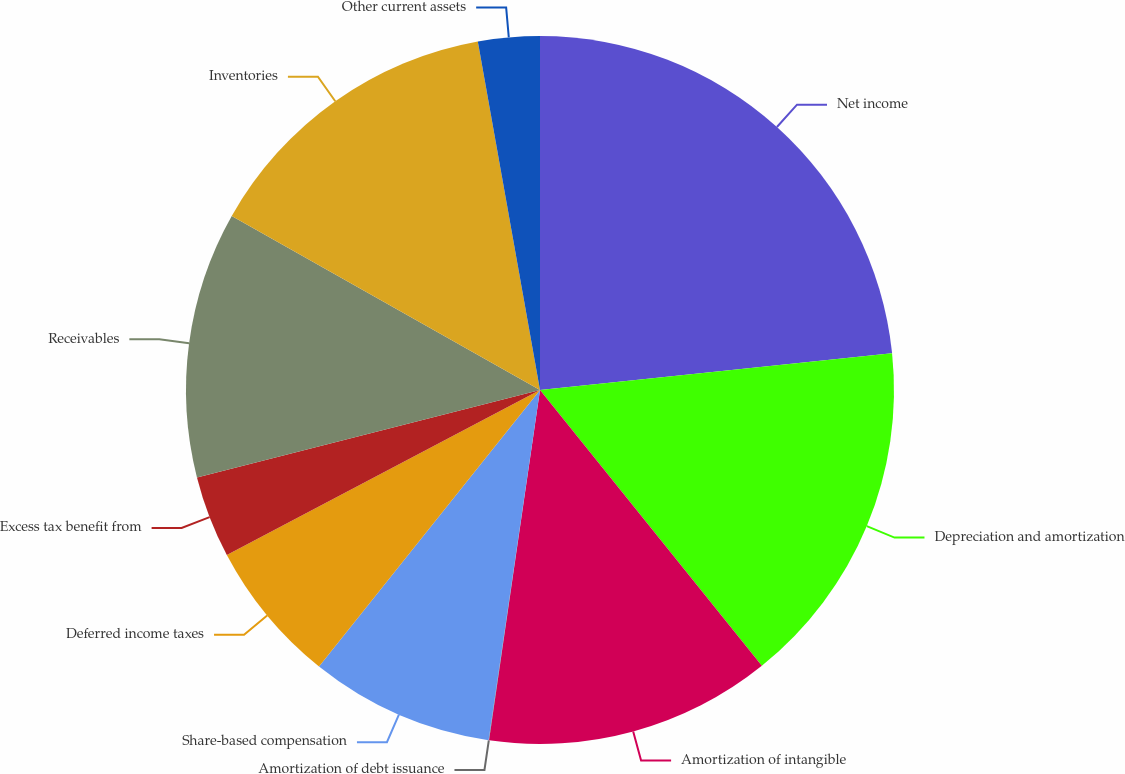Convert chart to OTSL. <chart><loc_0><loc_0><loc_500><loc_500><pie_chart><fcel>Net income<fcel>Depreciation and amortization<fcel>Amortization of intangible<fcel>Amortization of debt issuance<fcel>Share-based compensation<fcel>Deferred income taxes<fcel>Excess tax benefit from<fcel>Receivables<fcel>Inventories<fcel>Other current assets<nl><fcel>23.34%<fcel>15.88%<fcel>13.08%<fcel>0.02%<fcel>8.41%<fcel>6.55%<fcel>3.75%<fcel>12.15%<fcel>14.01%<fcel>2.81%<nl></chart> 